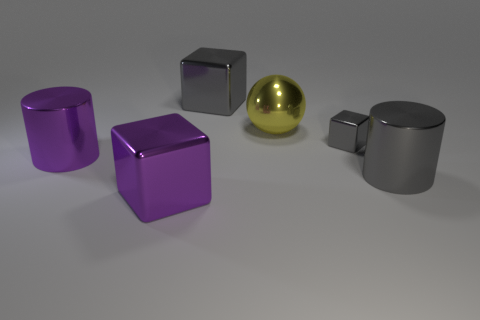Add 3 purple rubber objects. How many objects exist? 9 Subtract all big metallic cubes. How many cubes are left? 1 Add 1 big red metallic spheres. How many big red metallic spheres exist? 1 Subtract all purple blocks. How many blocks are left? 2 Subtract 0 blue cylinders. How many objects are left? 6 Subtract all balls. How many objects are left? 5 Subtract 2 cubes. How many cubes are left? 1 Subtract all blue blocks. Subtract all gray balls. How many blocks are left? 3 Subtract all blue cylinders. How many gray cubes are left? 2 Subtract all tiny gray matte cylinders. Subtract all metal blocks. How many objects are left? 3 